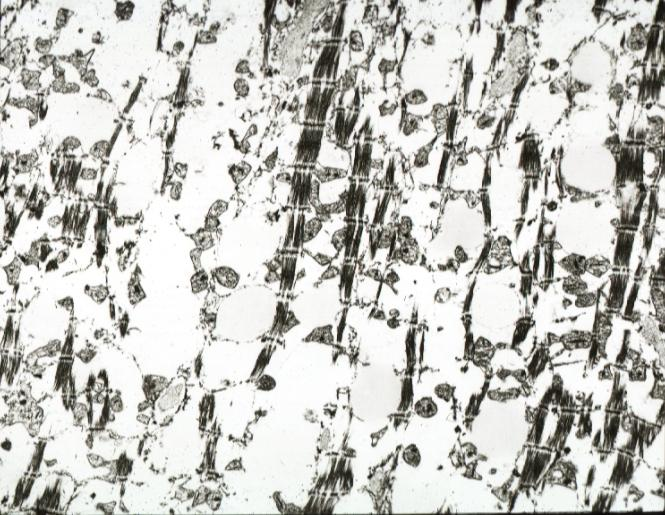s conjoined twins present?
Answer the question using a single word or phrase. No 